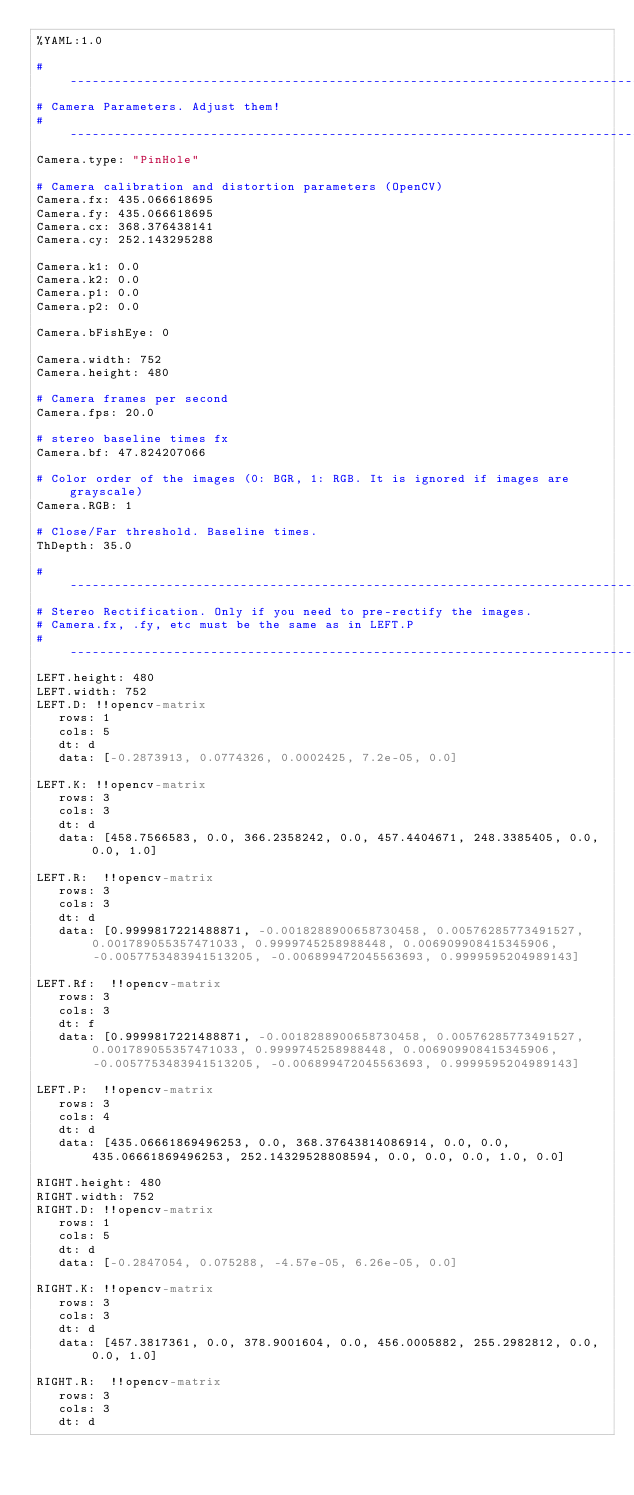Convert code to text. <code><loc_0><loc_0><loc_500><loc_500><_YAML_>%YAML:1.0

#--------------------------------------------------------------------------------------------
# Camera Parameters. Adjust them!
#--------------------------------------------------------------------------------------------
Camera.type: "PinHole"

# Camera calibration and distortion parameters (OpenCV)
Camera.fx: 435.066618695
Camera.fy: 435.066618695
Camera.cx: 368.376438141
Camera.cy: 252.143295288

Camera.k1: 0.0
Camera.k2: 0.0
Camera.p1: 0.0
Camera.p2: 0.0

Camera.bFishEye: 0

Camera.width: 752
Camera.height: 480

# Camera frames per second
Camera.fps: 20.0

# stereo baseline times fx
Camera.bf: 47.824207066

# Color order of the images (0: BGR, 1: RGB. It is ignored if images are grayscale)
Camera.RGB: 1

# Close/Far threshold. Baseline times.
ThDepth: 35.0

#--------------------------------------------------------------------------------------------
# Stereo Rectification. Only if you need to pre-rectify the images.
# Camera.fx, .fy, etc must be the same as in LEFT.P
#--------------------------------------------------------------------------------------------
LEFT.height: 480
LEFT.width: 752
LEFT.D: !!opencv-matrix
   rows: 1
   cols: 5
   dt: d
   data: [-0.2873913, 0.0774326, 0.0002425, 7.2e-05, 0.0]

LEFT.K: !!opencv-matrix
   rows: 3
   cols: 3
   dt: d
   data: [458.7566583, 0.0, 366.2358242, 0.0, 457.4404671, 248.3385405, 0.0, 0.0, 1.0]

LEFT.R:  !!opencv-matrix
   rows: 3
   cols: 3
   dt: d
   data: [0.9999817221488871, -0.0018288900658730458, 0.00576285773491527, 0.001789055357471033, 0.9999745258988448, 0.006909908415345906, -0.0057753483941513205, -0.006899472045563693, 0.9999595204989143]

LEFT.Rf:  !!opencv-matrix
   rows: 3
   cols: 3
   dt: f
   data: [0.9999817221488871, -0.0018288900658730458, 0.00576285773491527, 0.001789055357471033, 0.9999745258988448, 0.006909908415345906, -0.0057753483941513205, -0.006899472045563693, 0.9999595204989143]

LEFT.P:  !!opencv-matrix
   rows: 3
   cols: 4
   dt: d
   data: [435.06661869496253, 0.0, 368.37643814086914, 0.0, 0.0, 435.06661869496253, 252.14329528808594, 0.0, 0.0, 0.0, 1.0, 0.0]

RIGHT.height: 480
RIGHT.width: 752
RIGHT.D: !!opencv-matrix
   rows: 1
   cols: 5
   dt: d
   data: [-0.2847054, 0.075288, -4.57e-05, 6.26e-05, 0.0]

RIGHT.K: !!opencv-matrix
   rows: 3
   cols: 3
   dt: d
   data: [457.3817361, 0.0, 378.9001604, 0.0, 456.0005882, 255.2982812, 0.0, 0.0, 1.0]

RIGHT.R:  !!opencv-matrix
   rows: 3
   cols: 3
   dt: d</code> 